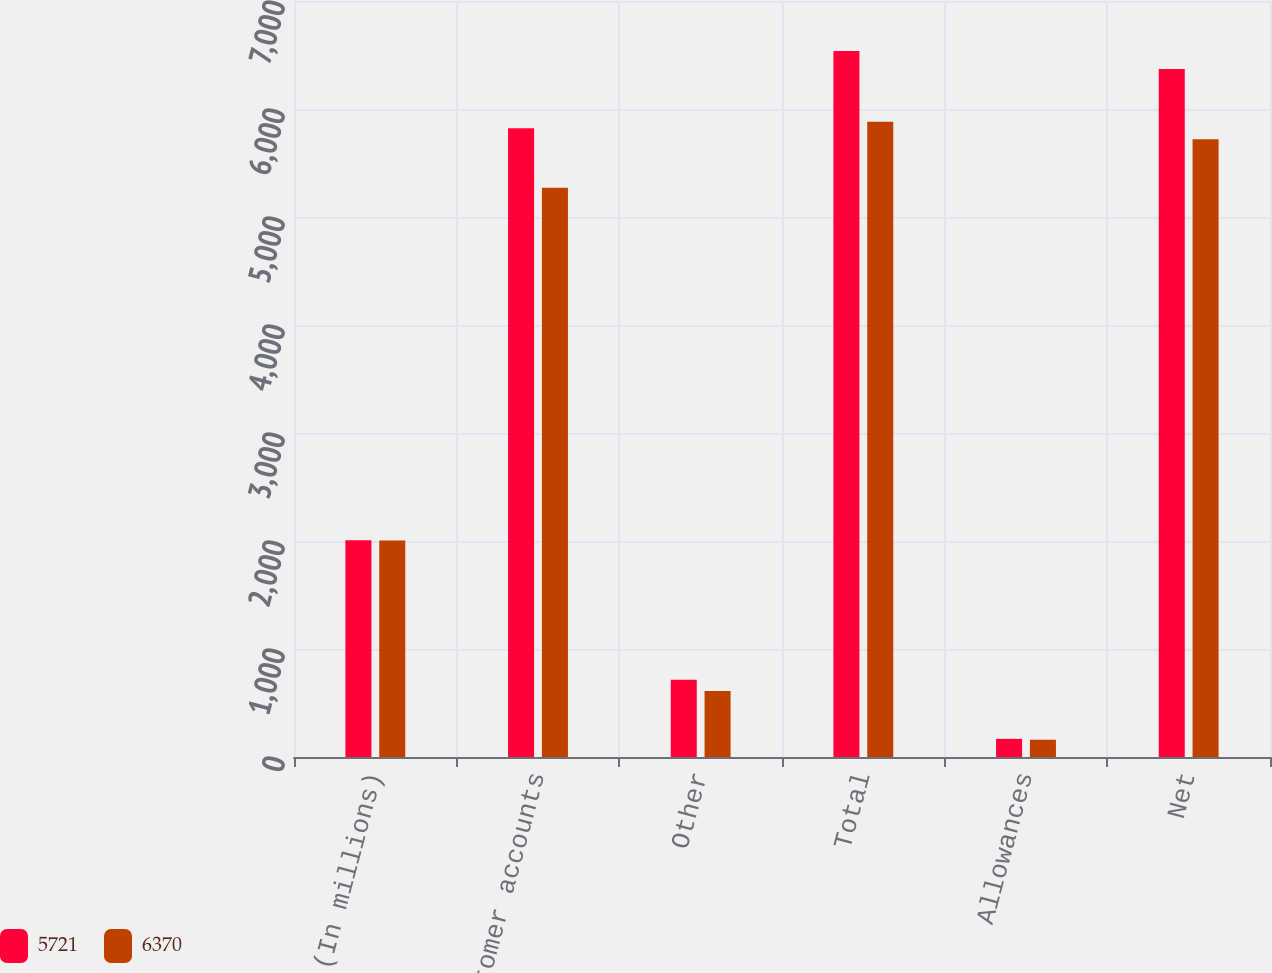Convert chart. <chart><loc_0><loc_0><loc_500><loc_500><stacked_bar_chart><ecel><fcel>(In millions)<fcel>Customer accounts<fcel>Other<fcel>Total<fcel>Allowances<fcel>Net<nl><fcel>5721<fcel>2006<fcel>5822<fcel>716<fcel>6538<fcel>168<fcel>6370<nl><fcel>6370<fcel>2005<fcel>5271<fcel>610<fcel>5881<fcel>160<fcel>5721<nl></chart> 